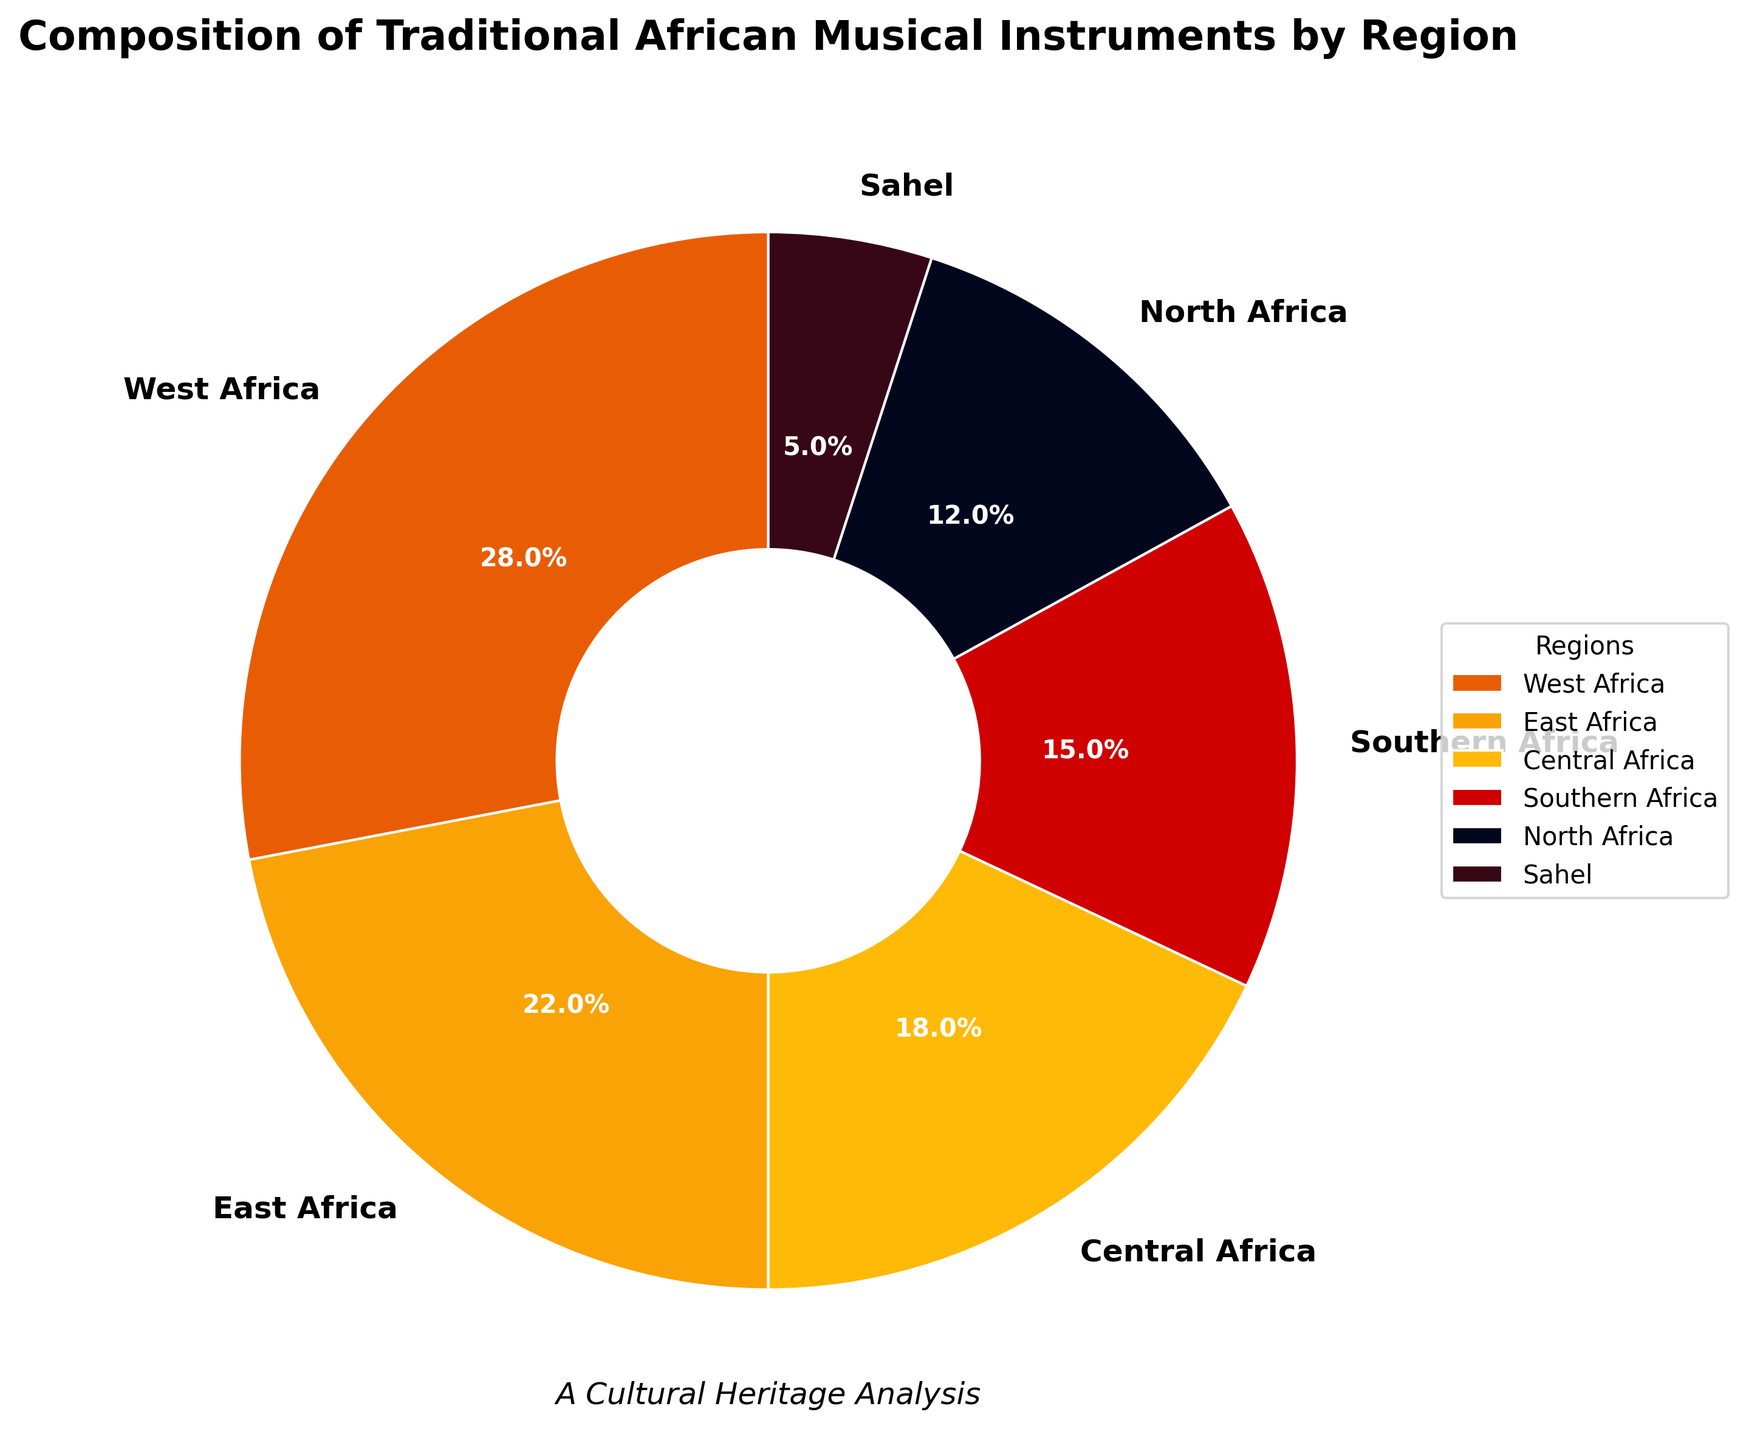What is the region with the highest percentage of traditional African musical instruments? The region with the highest percentage can be found by looking at the region with the largest slice in the pie chart. The largest slice belongs to West Africa with 28%.
Answer: West Africa What is the total percentage of traditional African musical instruments in East Africa and Central Africa? Add the percentages of East Africa and Central Africa from the chart: 22% (East Africa) + 18% (Central Africa) = 40%.
Answer: 40% Which region has a smaller percentage of traditional African musical instruments, North Africa or Sahel? Compare the percentages of North Africa (12%) and Sahel (5%) from the chart. North Africa has a larger percentage, so Sahel has a smaller percentage.
Answer: Sahel How much higher is the percentage of traditional African musical instruments in West Africa compared to Southern Africa? Subtract the percentage of Southern Africa from West Africa: 28% (West Africa) - 15% (Southern Africa) = 13%.
Answer: 13% List the regions in descending order based on their percentages of traditional African musical instruments. Arrange the regions by their displayed percentages in descending order: West Africa (28%), East Africa (22%), Central Africa (18%), Southern Africa (15%), North Africa (12%), Sahel (5%).
Answer: West Africa, East Africa, Central Africa, Southern Africa, North Africa, Sahel What is the visual color representing North Africa, and how does it compare to the color of the Sahel? North Africa is represented by a dark blue hue, whereas Sahel is represented by a dark red hue. The colors are different and can be distinguished clearly in the chart.
Answer: Dark blue for North Africa, dark red for Sahel Which two regions together comprise roughly half of the traditional African musical instruments? Add the percentages of major regions until the sum approximates 50%. West Africa (28%) + East Africa (22%) = 50%. These two regions combined make up roughly half of the chart.
Answer: West Africa and East Africa How does the share of traditional African musical instruments in Central Africa compare to the total share in the combined Southern Africa and North Africa regions? Compare Central Africa (18%) with the sum of Southern Africa (15%) and North Africa (12%). 15% + 12% = 27%, which is more than the 18% of Central Africa.
Answer: Central Africa is less What's the difference in percentage between the region with the highest proportion and the region with the lowest proportion of traditional African musical instruments? Subtract the percentage of the region with the lowest proportion (Sahel, 5%) from the percentage of the region with the highest proportion (West Africa, 28%): 28% - 5% = 23%.
Answer: 23% 